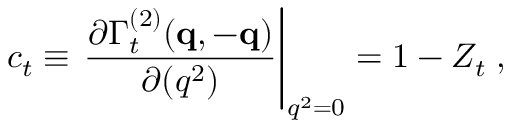<formula> <loc_0><loc_0><loc_500><loc_500>c _ { t } \equiv \frac { \partial \Gamma _ { t } ^ { ( 2 ) } ( { q } , - { q } ) } { \partial ( q ^ { 2 } ) } \right | _ { q ^ { 2 } = 0 } = 1 - Z _ { t } \, ,</formula> 